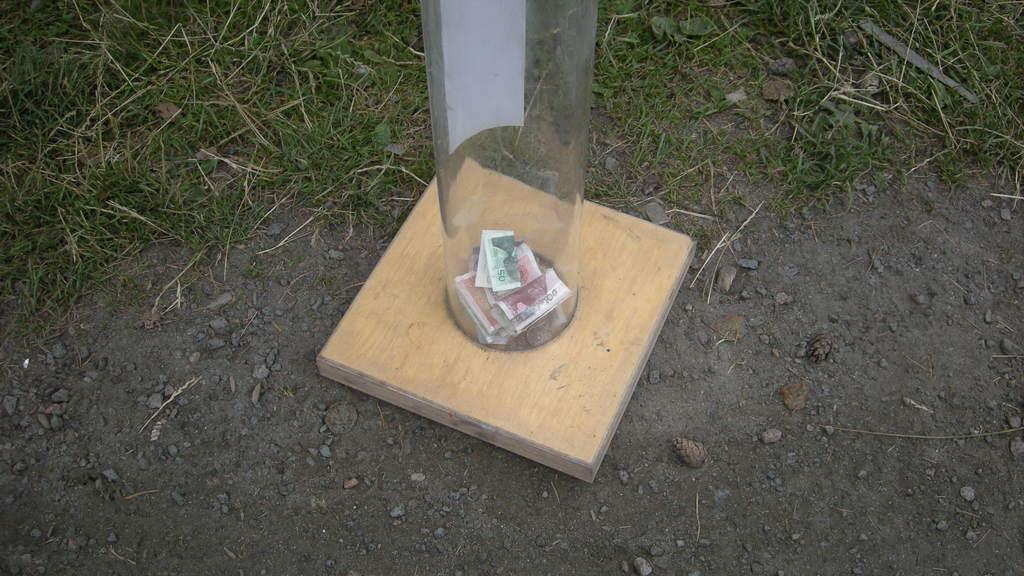What is inside the glass container in the image? There is currency in a glass container in the image. What type of vegetation can be seen in the image? There is grass visible in the image. What type of berry is growing on the grass in the image? There is no berry present in the image; only grass is visible. 